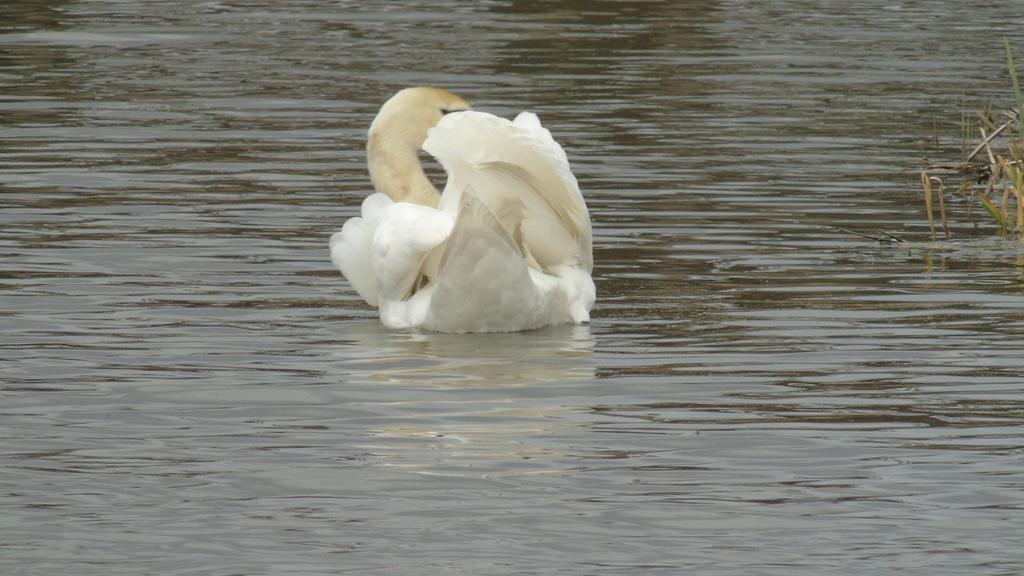What type of animal is in the image? There is a white swan in the image. What is the swan doing in the image? The swan is swimming on the water. What can be seen on the right side of the image? There are plants on the right side of the image. Where is the shop located in the image? There is no shop present in the image. What type of muscle is being exercised by the swan in the image? The image does not show the swan exercising any muscles; it is simply swimming on the water. 